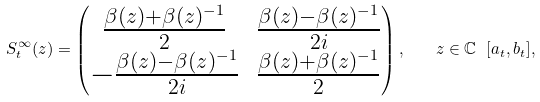Convert formula to latex. <formula><loc_0><loc_0><loc_500><loc_500>S ^ { \infty } _ { t } ( z ) = \begin{pmatrix} \frac { \beta ( z ) + \beta ( z ) ^ { - 1 } } { 2 } & \frac { \beta ( z ) - \beta ( z ) ^ { - 1 } } { 2 i } \\ - \frac { \beta ( z ) - \beta ( z ) ^ { - 1 } } { 2 i } & \frac { \beta ( z ) + \beta ( z ) ^ { - 1 } } { 2 } \\ \end{pmatrix} , \quad z \in \mathbb { C } \ [ a _ { t } , b _ { t } ] ,</formula> 